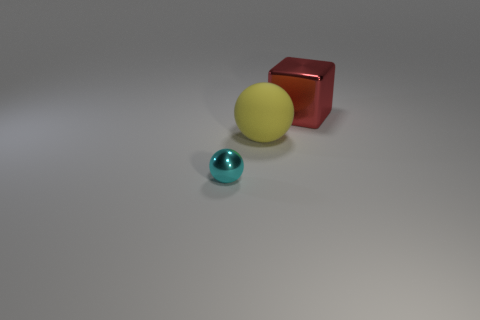Add 1 spheres. How many objects exist? 4 Subtract all spheres. How many objects are left? 1 Subtract 0 red cylinders. How many objects are left? 3 Subtract all big gray spheres. Subtract all big yellow balls. How many objects are left? 2 Add 1 cubes. How many cubes are left? 2 Add 1 rubber objects. How many rubber objects exist? 2 